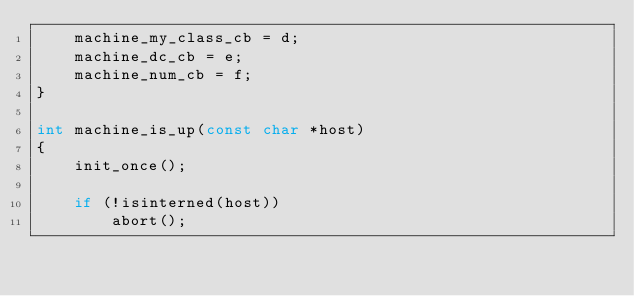<code> <loc_0><loc_0><loc_500><loc_500><_C_>    machine_my_class_cb = d;
    machine_dc_cb = e;
    machine_num_cb = f;
}

int machine_is_up(const char *host)
{
    init_once();

    if (!isinterned(host))
        abort();
</code> 